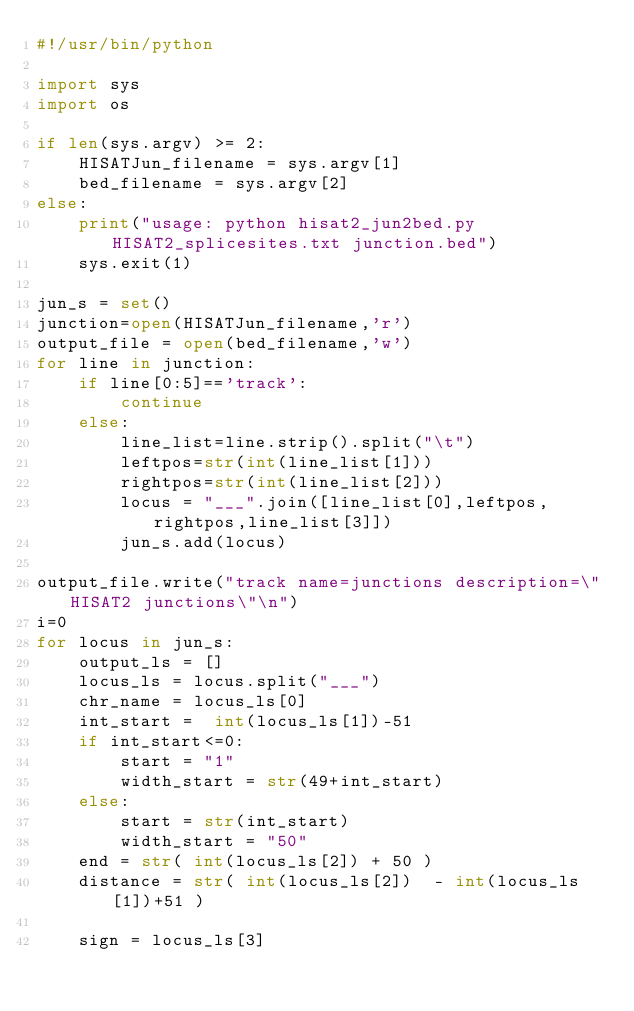Convert code to text. <code><loc_0><loc_0><loc_500><loc_500><_Python_>#!/usr/bin/python

import sys
import os

if len(sys.argv) >= 2:
    HISATJun_filename = sys.argv[1]
    bed_filename = sys.argv[2]
else:
    print("usage: python hisat2_jun2bed.py HISAT2_splicesites.txt junction.bed")
    sys.exit(1)

jun_s = set()
junction=open(HISATJun_filename,'r')
output_file = open(bed_filename,'w')
for line in junction:
    if line[0:5]=='track':
        continue
    else:
        line_list=line.strip().split("\t")
        leftpos=str(int(line_list[1]))
        rightpos=str(int(line_list[2]))
        locus = "___".join([line_list[0],leftpos,rightpos,line_list[3]])
        jun_s.add(locus)

output_file.write("track name=junctions description=\"HISAT2 junctions\"\n")
i=0
for locus in jun_s:
    output_ls = []
    locus_ls = locus.split("___")
    chr_name = locus_ls[0]
    int_start =  int(locus_ls[1])-51
    if int_start<=0:
        start = "1"
        width_start = str(49+int_start)
    else:
        start = str(int_start)
        width_start = "50"
    end = str( int(locus_ls[2]) + 50 )
    distance = str( int(locus_ls[2])  - int(locus_ls[1])+51 )

    sign = locus_ls[3]
</code> 